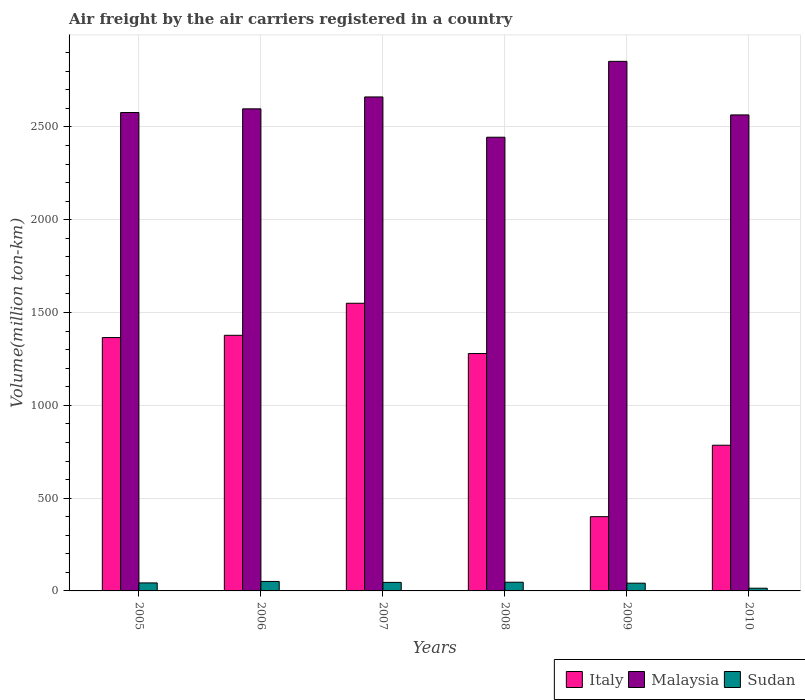Are the number of bars per tick equal to the number of legend labels?
Make the answer very short. Yes. How many bars are there on the 6th tick from the right?
Your response must be concise. 3. In how many cases, is the number of bars for a given year not equal to the number of legend labels?
Your answer should be compact. 0. What is the volume of the air carriers in Sudan in 2010?
Your response must be concise. 14.64. Across all years, what is the maximum volume of the air carriers in Italy?
Your response must be concise. 1549.94. In which year was the volume of the air carriers in Italy maximum?
Make the answer very short. 2007. In which year was the volume of the air carriers in Malaysia minimum?
Provide a succinct answer. 2008. What is the total volume of the air carriers in Malaysia in the graph?
Offer a very short reply. 1.57e+04. What is the difference between the volume of the air carriers in Italy in 2007 and that in 2009?
Ensure brevity in your answer.  1149.94. What is the difference between the volume of the air carriers in Italy in 2010 and the volume of the air carriers in Malaysia in 2009?
Provide a short and direct response. -2068.29. What is the average volume of the air carriers in Italy per year?
Keep it short and to the point. 1126.04. In the year 2009, what is the difference between the volume of the air carriers in Italy and volume of the air carriers in Malaysia?
Make the answer very short. -2453.26. What is the ratio of the volume of the air carriers in Sudan in 2007 to that in 2008?
Offer a very short reply. 0.98. Is the difference between the volume of the air carriers in Italy in 2005 and 2006 greater than the difference between the volume of the air carriers in Malaysia in 2005 and 2006?
Ensure brevity in your answer.  Yes. What is the difference between the highest and the second highest volume of the air carriers in Italy?
Ensure brevity in your answer.  172.74. What is the difference between the highest and the lowest volume of the air carriers in Malaysia?
Provide a short and direct response. 408.8. Is the sum of the volume of the air carriers in Sudan in 2006 and 2008 greater than the maximum volume of the air carriers in Malaysia across all years?
Offer a terse response. No. What does the 3rd bar from the left in 2008 represents?
Offer a very short reply. Sudan. What does the 1st bar from the right in 2005 represents?
Make the answer very short. Sudan. How many bars are there?
Make the answer very short. 18. Are the values on the major ticks of Y-axis written in scientific E-notation?
Offer a terse response. No. Does the graph contain any zero values?
Keep it short and to the point. No. Does the graph contain grids?
Your response must be concise. Yes. Where does the legend appear in the graph?
Provide a succinct answer. Bottom right. How many legend labels are there?
Your response must be concise. 3. How are the legend labels stacked?
Keep it short and to the point. Horizontal. What is the title of the graph?
Make the answer very short. Air freight by the air carriers registered in a country. Does "Greenland" appear as one of the legend labels in the graph?
Offer a very short reply. No. What is the label or title of the Y-axis?
Ensure brevity in your answer.  Volume(million ton-km). What is the Volume(million ton-km) of Italy in 2005?
Provide a short and direct response. 1365.13. What is the Volume(million ton-km) in Malaysia in 2005?
Keep it short and to the point. 2577.58. What is the Volume(million ton-km) in Sudan in 2005?
Give a very brief answer. 43.12. What is the Volume(million ton-km) of Italy in 2006?
Make the answer very short. 1377.2. What is the Volume(million ton-km) of Malaysia in 2006?
Offer a terse response. 2597.4. What is the Volume(million ton-km) of Sudan in 2006?
Provide a short and direct response. 51.04. What is the Volume(million ton-km) in Italy in 2007?
Offer a very short reply. 1549.94. What is the Volume(million ton-km) of Malaysia in 2007?
Your answer should be very brief. 2661.53. What is the Volume(million ton-km) in Sudan in 2007?
Offer a very short reply. 45.89. What is the Volume(million ton-km) of Italy in 2008?
Provide a succinct answer. 1279.02. What is the Volume(million ton-km) of Malaysia in 2008?
Offer a terse response. 2444.46. What is the Volume(million ton-km) of Sudan in 2008?
Keep it short and to the point. 46.82. What is the Volume(million ton-km) of Malaysia in 2009?
Provide a short and direct response. 2853.26. What is the Volume(million ton-km) in Sudan in 2009?
Provide a succinct answer. 41.8. What is the Volume(million ton-km) in Italy in 2010?
Ensure brevity in your answer.  784.97. What is the Volume(million ton-km) in Malaysia in 2010?
Provide a short and direct response. 2564.66. What is the Volume(million ton-km) of Sudan in 2010?
Give a very brief answer. 14.64. Across all years, what is the maximum Volume(million ton-km) in Italy?
Give a very brief answer. 1549.94. Across all years, what is the maximum Volume(million ton-km) of Malaysia?
Your answer should be very brief. 2853.26. Across all years, what is the maximum Volume(million ton-km) of Sudan?
Offer a very short reply. 51.04. Across all years, what is the minimum Volume(million ton-km) of Malaysia?
Give a very brief answer. 2444.46. Across all years, what is the minimum Volume(million ton-km) of Sudan?
Offer a very short reply. 14.64. What is the total Volume(million ton-km) in Italy in the graph?
Your answer should be compact. 6756.26. What is the total Volume(million ton-km) in Malaysia in the graph?
Your response must be concise. 1.57e+04. What is the total Volume(million ton-km) of Sudan in the graph?
Provide a short and direct response. 243.31. What is the difference between the Volume(million ton-km) in Italy in 2005 and that in 2006?
Provide a succinct answer. -12.08. What is the difference between the Volume(million ton-km) of Malaysia in 2005 and that in 2006?
Make the answer very short. -19.82. What is the difference between the Volume(million ton-km) of Sudan in 2005 and that in 2006?
Your answer should be very brief. -7.92. What is the difference between the Volume(million ton-km) in Italy in 2005 and that in 2007?
Ensure brevity in your answer.  -184.81. What is the difference between the Volume(million ton-km) of Malaysia in 2005 and that in 2007?
Offer a very short reply. -83.95. What is the difference between the Volume(million ton-km) of Sudan in 2005 and that in 2007?
Offer a terse response. -2.77. What is the difference between the Volume(million ton-km) in Italy in 2005 and that in 2008?
Your response must be concise. 86.11. What is the difference between the Volume(million ton-km) of Malaysia in 2005 and that in 2008?
Provide a succinct answer. 133.12. What is the difference between the Volume(million ton-km) in Sudan in 2005 and that in 2008?
Offer a terse response. -3.7. What is the difference between the Volume(million ton-km) of Italy in 2005 and that in 2009?
Provide a succinct answer. 965.13. What is the difference between the Volume(million ton-km) in Malaysia in 2005 and that in 2009?
Give a very brief answer. -275.68. What is the difference between the Volume(million ton-km) of Sudan in 2005 and that in 2009?
Make the answer very short. 1.31. What is the difference between the Volume(million ton-km) of Italy in 2005 and that in 2010?
Your answer should be compact. 580.16. What is the difference between the Volume(million ton-km) in Malaysia in 2005 and that in 2010?
Keep it short and to the point. 12.92. What is the difference between the Volume(million ton-km) of Sudan in 2005 and that in 2010?
Offer a terse response. 28.48. What is the difference between the Volume(million ton-km) in Italy in 2006 and that in 2007?
Provide a succinct answer. -172.74. What is the difference between the Volume(million ton-km) of Malaysia in 2006 and that in 2007?
Make the answer very short. -64.12. What is the difference between the Volume(million ton-km) in Sudan in 2006 and that in 2007?
Offer a very short reply. 5.15. What is the difference between the Volume(million ton-km) in Italy in 2006 and that in 2008?
Ensure brevity in your answer.  98.18. What is the difference between the Volume(million ton-km) in Malaysia in 2006 and that in 2008?
Your response must be concise. 152.94. What is the difference between the Volume(million ton-km) in Sudan in 2006 and that in 2008?
Provide a succinct answer. 4.22. What is the difference between the Volume(million ton-km) of Italy in 2006 and that in 2009?
Your response must be concise. 977.2. What is the difference between the Volume(million ton-km) of Malaysia in 2006 and that in 2009?
Offer a terse response. -255.86. What is the difference between the Volume(million ton-km) in Sudan in 2006 and that in 2009?
Provide a short and direct response. 9.24. What is the difference between the Volume(million ton-km) of Italy in 2006 and that in 2010?
Your answer should be very brief. 592.23. What is the difference between the Volume(million ton-km) in Malaysia in 2006 and that in 2010?
Give a very brief answer. 32.75. What is the difference between the Volume(million ton-km) of Sudan in 2006 and that in 2010?
Your response must be concise. 36.4. What is the difference between the Volume(million ton-km) in Italy in 2007 and that in 2008?
Keep it short and to the point. 270.92. What is the difference between the Volume(million ton-km) of Malaysia in 2007 and that in 2008?
Offer a terse response. 217.07. What is the difference between the Volume(million ton-km) in Sudan in 2007 and that in 2008?
Provide a succinct answer. -0.93. What is the difference between the Volume(million ton-km) in Italy in 2007 and that in 2009?
Your answer should be compact. 1149.94. What is the difference between the Volume(million ton-km) of Malaysia in 2007 and that in 2009?
Provide a succinct answer. -191.74. What is the difference between the Volume(million ton-km) in Sudan in 2007 and that in 2009?
Your answer should be compact. 4.09. What is the difference between the Volume(million ton-km) in Italy in 2007 and that in 2010?
Make the answer very short. 764.97. What is the difference between the Volume(million ton-km) in Malaysia in 2007 and that in 2010?
Provide a succinct answer. 96.87. What is the difference between the Volume(million ton-km) of Sudan in 2007 and that in 2010?
Your answer should be compact. 31.25. What is the difference between the Volume(million ton-km) of Italy in 2008 and that in 2009?
Provide a succinct answer. 879.02. What is the difference between the Volume(million ton-km) in Malaysia in 2008 and that in 2009?
Your response must be concise. -408.8. What is the difference between the Volume(million ton-km) of Sudan in 2008 and that in 2009?
Keep it short and to the point. 5.02. What is the difference between the Volume(million ton-km) of Italy in 2008 and that in 2010?
Ensure brevity in your answer.  494.05. What is the difference between the Volume(million ton-km) of Malaysia in 2008 and that in 2010?
Offer a very short reply. -120.2. What is the difference between the Volume(million ton-km) of Sudan in 2008 and that in 2010?
Your answer should be very brief. 32.18. What is the difference between the Volume(million ton-km) of Italy in 2009 and that in 2010?
Offer a terse response. -384.97. What is the difference between the Volume(million ton-km) in Malaysia in 2009 and that in 2010?
Provide a succinct answer. 288.6. What is the difference between the Volume(million ton-km) in Sudan in 2009 and that in 2010?
Make the answer very short. 27.16. What is the difference between the Volume(million ton-km) of Italy in 2005 and the Volume(million ton-km) of Malaysia in 2006?
Keep it short and to the point. -1232.28. What is the difference between the Volume(million ton-km) of Italy in 2005 and the Volume(million ton-km) of Sudan in 2006?
Your answer should be very brief. 1314.09. What is the difference between the Volume(million ton-km) of Malaysia in 2005 and the Volume(million ton-km) of Sudan in 2006?
Your response must be concise. 2526.54. What is the difference between the Volume(million ton-km) of Italy in 2005 and the Volume(million ton-km) of Malaysia in 2007?
Ensure brevity in your answer.  -1296.4. What is the difference between the Volume(million ton-km) of Italy in 2005 and the Volume(million ton-km) of Sudan in 2007?
Provide a succinct answer. 1319.24. What is the difference between the Volume(million ton-km) in Malaysia in 2005 and the Volume(million ton-km) in Sudan in 2007?
Give a very brief answer. 2531.69. What is the difference between the Volume(million ton-km) in Italy in 2005 and the Volume(million ton-km) in Malaysia in 2008?
Your answer should be compact. -1079.33. What is the difference between the Volume(million ton-km) in Italy in 2005 and the Volume(million ton-km) in Sudan in 2008?
Provide a short and direct response. 1318.31. What is the difference between the Volume(million ton-km) in Malaysia in 2005 and the Volume(million ton-km) in Sudan in 2008?
Your answer should be compact. 2530.76. What is the difference between the Volume(million ton-km) in Italy in 2005 and the Volume(million ton-km) in Malaysia in 2009?
Keep it short and to the point. -1488.13. What is the difference between the Volume(million ton-km) of Italy in 2005 and the Volume(million ton-km) of Sudan in 2009?
Make the answer very short. 1323.33. What is the difference between the Volume(million ton-km) in Malaysia in 2005 and the Volume(million ton-km) in Sudan in 2009?
Your response must be concise. 2535.78. What is the difference between the Volume(million ton-km) of Italy in 2005 and the Volume(million ton-km) of Malaysia in 2010?
Offer a very short reply. -1199.53. What is the difference between the Volume(million ton-km) in Italy in 2005 and the Volume(million ton-km) in Sudan in 2010?
Make the answer very short. 1350.49. What is the difference between the Volume(million ton-km) in Malaysia in 2005 and the Volume(million ton-km) in Sudan in 2010?
Make the answer very short. 2562.94. What is the difference between the Volume(million ton-km) of Italy in 2006 and the Volume(million ton-km) of Malaysia in 2007?
Offer a terse response. -1284.32. What is the difference between the Volume(million ton-km) of Italy in 2006 and the Volume(million ton-km) of Sudan in 2007?
Your answer should be very brief. 1331.31. What is the difference between the Volume(million ton-km) of Malaysia in 2006 and the Volume(million ton-km) of Sudan in 2007?
Offer a very short reply. 2551.51. What is the difference between the Volume(million ton-km) in Italy in 2006 and the Volume(million ton-km) in Malaysia in 2008?
Offer a terse response. -1067.26. What is the difference between the Volume(million ton-km) in Italy in 2006 and the Volume(million ton-km) in Sudan in 2008?
Offer a very short reply. 1330.38. What is the difference between the Volume(million ton-km) of Malaysia in 2006 and the Volume(million ton-km) of Sudan in 2008?
Provide a succinct answer. 2550.58. What is the difference between the Volume(million ton-km) in Italy in 2006 and the Volume(million ton-km) in Malaysia in 2009?
Keep it short and to the point. -1476.06. What is the difference between the Volume(million ton-km) of Italy in 2006 and the Volume(million ton-km) of Sudan in 2009?
Offer a terse response. 1335.4. What is the difference between the Volume(million ton-km) in Malaysia in 2006 and the Volume(million ton-km) in Sudan in 2009?
Ensure brevity in your answer.  2555.6. What is the difference between the Volume(million ton-km) of Italy in 2006 and the Volume(million ton-km) of Malaysia in 2010?
Provide a succinct answer. -1187.45. What is the difference between the Volume(million ton-km) of Italy in 2006 and the Volume(million ton-km) of Sudan in 2010?
Give a very brief answer. 1362.57. What is the difference between the Volume(million ton-km) of Malaysia in 2006 and the Volume(million ton-km) of Sudan in 2010?
Ensure brevity in your answer.  2582.77. What is the difference between the Volume(million ton-km) in Italy in 2007 and the Volume(million ton-km) in Malaysia in 2008?
Provide a short and direct response. -894.52. What is the difference between the Volume(million ton-km) of Italy in 2007 and the Volume(million ton-km) of Sudan in 2008?
Provide a succinct answer. 1503.12. What is the difference between the Volume(million ton-km) in Malaysia in 2007 and the Volume(million ton-km) in Sudan in 2008?
Offer a terse response. 2614.71. What is the difference between the Volume(million ton-km) of Italy in 2007 and the Volume(million ton-km) of Malaysia in 2009?
Keep it short and to the point. -1303.32. What is the difference between the Volume(million ton-km) of Italy in 2007 and the Volume(million ton-km) of Sudan in 2009?
Provide a short and direct response. 1508.14. What is the difference between the Volume(million ton-km) of Malaysia in 2007 and the Volume(million ton-km) of Sudan in 2009?
Keep it short and to the point. 2619.72. What is the difference between the Volume(million ton-km) in Italy in 2007 and the Volume(million ton-km) in Malaysia in 2010?
Provide a short and direct response. -1014.72. What is the difference between the Volume(million ton-km) of Italy in 2007 and the Volume(million ton-km) of Sudan in 2010?
Provide a short and direct response. 1535.3. What is the difference between the Volume(million ton-km) of Malaysia in 2007 and the Volume(million ton-km) of Sudan in 2010?
Ensure brevity in your answer.  2646.89. What is the difference between the Volume(million ton-km) in Italy in 2008 and the Volume(million ton-km) in Malaysia in 2009?
Provide a succinct answer. -1574.24. What is the difference between the Volume(million ton-km) of Italy in 2008 and the Volume(million ton-km) of Sudan in 2009?
Your answer should be very brief. 1237.22. What is the difference between the Volume(million ton-km) of Malaysia in 2008 and the Volume(million ton-km) of Sudan in 2009?
Offer a very short reply. 2402.66. What is the difference between the Volume(million ton-km) in Italy in 2008 and the Volume(million ton-km) in Malaysia in 2010?
Your response must be concise. -1285.64. What is the difference between the Volume(million ton-km) of Italy in 2008 and the Volume(million ton-km) of Sudan in 2010?
Your response must be concise. 1264.38. What is the difference between the Volume(million ton-km) in Malaysia in 2008 and the Volume(million ton-km) in Sudan in 2010?
Your answer should be very brief. 2429.82. What is the difference between the Volume(million ton-km) of Italy in 2009 and the Volume(million ton-km) of Malaysia in 2010?
Provide a succinct answer. -2164.66. What is the difference between the Volume(million ton-km) of Italy in 2009 and the Volume(million ton-km) of Sudan in 2010?
Offer a terse response. 385.36. What is the difference between the Volume(million ton-km) in Malaysia in 2009 and the Volume(million ton-km) in Sudan in 2010?
Keep it short and to the point. 2838.62. What is the average Volume(million ton-km) in Italy per year?
Your answer should be compact. 1126.04. What is the average Volume(million ton-km) of Malaysia per year?
Ensure brevity in your answer.  2616.48. What is the average Volume(million ton-km) of Sudan per year?
Provide a short and direct response. 40.55. In the year 2005, what is the difference between the Volume(million ton-km) in Italy and Volume(million ton-km) in Malaysia?
Your response must be concise. -1212.45. In the year 2005, what is the difference between the Volume(million ton-km) in Italy and Volume(million ton-km) in Sudan?
Offer a very short reply. 1322.01. In the year 2005, what is the difference between the Volume(million ton-km) of Malaysia and Volume(million ton-km) of Sudan?
Make the answer very short. 2534.46. In the year 2006, what is the difference between the Volume(million ton-km) of Italy and Volume(million ton-km) of Malaysia?
Your answer should be compact. -1220.2. In the year 2006, what is the difference between the Volume(million ton-km) in Italy and Volume(million ton-km) in Sudan?
Provide a short and direct response. 1326.16. In the year 2006, what is the difference between the Volume(million ton-km) of Malaysia and Volume(million ton-km) of Sudan?
Your answer should be very brief. 2546.36. In the year 2007, what is the difference between the Volume(million ton-km) of Italy and Volume(million ton-km) of Malaysia?
Ensure brevity in your answer.  -1111.59. In the year 2007, what is the difference between the Volume(million ton-km) in Italy and Volume(million ton-km) in Sudan?
Provide a succinct answer. 1504.05. In the year 2007, what is the difference between the Volume(million ton-km) in Malaysia and Volume(million ton-km) in Sudan?
Provide a short and direct response. 2615.64. In the year 2008, what is the difference between the Volume(million ton-km) of Italy and Volume(million ton-km) of Malaysia?
Your answer should be very brief. -1165.44. In the year 2008, what is the difference between the Volume(million ton-km) of Italy and Volume(million ton-km) of Sudan?
Your answer should be compact. 1232.2. In the year 2008, what is the difference between the Volume(million ton-km) of Malaysia and Volume(million ton-km) of Sudan?
Your answer should be very brief. 2397.64. In the year 2009, what is the difference between the Volume(million ton-km) in Italy and Volume(million ton-km) in Malaysia?
Provide a short and direct response. -2453.26. In the year 2009, what is the difference between the Volume(million ton-km) of Italy and Volume(million ton-km) of Sudan?
Your answer should be very brief. 358.2. In the year 2009, what is the difference between the Volume(million ton-km) of Malaysia and Volume(million ton-km) of Sudan?
Your answer should be compact. 2811.46. In the year 2010, what is the difference between the Volume(million ton-km) of Italy and Volume(million ton-km) of Malaysia?
Your answer should be compact. -1779.69. In the year 2010, what is the difference between the Volume(million ton-km) in Italy and Volume(million ton-km) in Sudan?
Give a very brief answer. 770.33. In the year 2010, what is the difference between the Volume(million ton-km) in Malaysia and Volume(million ton-km) in Sudan?
Give a very brief answer. 2550.02. What is the ratio of the Volume(million ton-km) in Sudan in 2005 to that in 2006?
Your answer should be compact. 0.84. What is the ratio of the Volume(million ton-km) in Italy in 2005 to that in 2007?
Your answer should be compact. 0.88. What is the ratio of the Volume(million ton-km) in Malaysia in 2005 to that in 2007?
Your response must be concise. 0.97. What is the ratio of the Volume(million ton-km) of Sudan in 2005 to that in 2007?
Make the answer very short. 0.94. What is the ratio of the Volume(million ton-km) of Italy in 2005 to that in 2008?
Your answer should be compact. 1.07. What is the ratio of the Volume(million ton-km) in Malaysia in 2005 to that in 2008?
Your response must be concise. 1.05. What is the ratio of the Volume(million ton-km) of Sudan in 2005 to that in 2008?
Provide a short and direct response. 0.92. What is the ratio of the Volume(million ton-km) in Italy in 2005 to that in 2009?
Provide a short and direct response. 3.41. What is the ratio of the Volume(million ton-km) of Malaysia in 2005 to that in 2009?
Provide a succinct answer. 0.9. What is the ratio of the Volume(million ton-km) in Sudan in 2005 to that in 2009?
Offer a very short reply. 1.03. What is the ratio of the Volume(million ton-km) of Italy in 2005 to that in 2010?
Offer a very short reply. 1.74. What is the ratio of the Volume(million ton-km) of Sudan in 2005 to that in 2010?
Offer a terse response. 2.95. What is the ratio of the Volume(million ton-km) in Italy in 2006 to that in 2007?
Provide a succinct answer. 0.89. What is the ratio of the Volume(million ton-km) of Malaysia in 2006 to that in 2007?
Offer a very short reply. 0.98. What is the ratio of the Volume(million ton-km) in Sudan in 2006 to that in 2007?
Make the answer very short. 1.11. What is the ratio of the Volume(million ton-km) in Italy in 2006 to that in 2008?
Your response must be concise. 1.08. What is the ratio of the Volume(million ton-km) in Malaysia in 2006 to that in 2008?
Your answer should be compact. 1.06. What is the ratio of the Volume(million ton-km) of Sudan in 2006 to that in 2008?
Your response must be concise. 1.09. What is the ratio of the Volume(million ton-km) of Italy in 2006 to that in 2009?
Offer a very short reply. 3.44. What is the ratio of the Volume(million ton-km) in Malaysia in 2006 to that in 2009?
Your answer should be very brief. 0.91. What is the ratio of the Volume(million ton-km) in Sudan in 2006 to that in 2009?
Provide a succinct answer. 1.22. What is the ratio of the Volume(million ton-km) in Italy in 2006 to that in 2010?
Ensure brevity in your answer.  1.75. What is the ratio of the Volume(million ton-km) in Malaysia in 2006 to that in 2010?
Ensure brevity in your answer.  1.01. What is the ratio of the Volume(million ton-km) of Sudan in 2006 to that in 2010?
Give a very brief answer. 3.49. What is the ratio of the Volume(million ton-km) of Italy in 2007 to that in 2008?
Your answer should be very brief. 1.21. What is the ratio of the Volume(million ton-km) of Malaysia in 2007 to that in 2008?
Provide a succinct answer. 1.09. What is the ratio of the Volume(million ton-km) in Sudan in 2007 to that in 2008?
Offer a very short reply. 0.98. What is the ratio of the Volume(million ton-km) in Italy in 2007 to that in 2009?
Give a very brief answer. 3.87. What is the ratio of the Volume(million ton-km) of Malaysia in 2007 to that in 2009?
Your response must be concise. 0.93. What is the ratio of the Volume(million ton-km) of Sudan in 2007 to that in 2009?
Provide a succinct answer. 1.1. What is the ratio of the Volume(million ton-km) in Italy in 2007 to that in 2010?
Keep it short and to the point. 1.97. What is the ratio of the Volume(million ton-km) in Malaysia in 2007 to that in 2010?
Your answer should be compact. 1.04. What is the ratio of the Volume(million ton-km) of Sudan in 2007 to that in 2010?
Your answer should be compact. 3.14. What is the ratio of the Volume(million ton-km) of Italy in 2008 to that in 2009?
Provide a succinct answer. 3.2. What is the ratio of the Volume(million ton-km) in Malaysia in 2008 to that in 2009?
Your response must be concise. 0.86. What is the ratio of the Volume(million ton-km) of Sudan in 2008 to that in 2009?
Make the answer very short. 1.12. What is the ratio of the Volume(million ton-km) of Italy in 2008 to that in 2010?
Offer a very short reply. 1.63. What is the ratio of the Volume(million ton-km) of Malaysia in 2008 to that in 2010?
Provide a short and direct response. 0.95. What is the ratio of the Volume(million ton-km) of Sudan in 2008 to that in 2010?
Offer a very short reply. 3.2. What is the ratio of the Volume(million ton-km) of Italy in 2009 to that in 2010?
Give a very brief answer. 0.51. What is the ratio of the Volume(million ton-km) in Malaysia in 2009 to that in 2010?
Give a very brief answer. 1.11. What is the ratio of the Volume(million ton-km) of Sudan in 2009 to that in 2010?
Ensure brevity in your answer.  2.86. What is the difference between the highest and the second highest Volume(million ton-km) of Italy?
Ensure brevity in your answer.  172.74. What is the difference between the highest and the second highest Volume(million ton-km) in Malaysia?
Give a very brief answer. 191.74. What is the difference between the highest and the second highest Volume(million ton-km) of Sudan?
Offer a terse response. 4.22. What is the difference between the highest and the lowest Volume(million ton-km) of Italy?
Your response must be concise. 1149.94. What is the difference between the highest and the lowest Volume(million ton-km) of Malaysia?
Offer a terse response. 408.8. What is the difference between the highest and the lowest Volume(million ton-km) in Sudan?
Offer a very short reply. 36.4. 